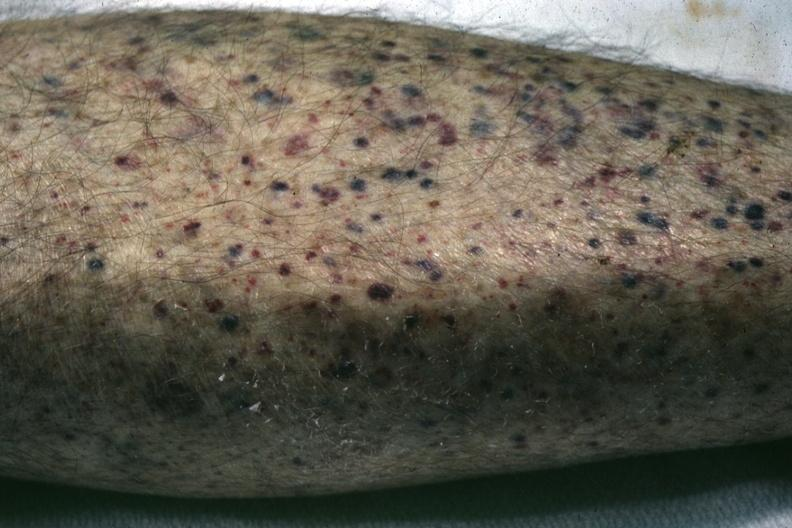does this image show white skin close-up view quite good?
Answer the question using a single word or phrase. Yes 